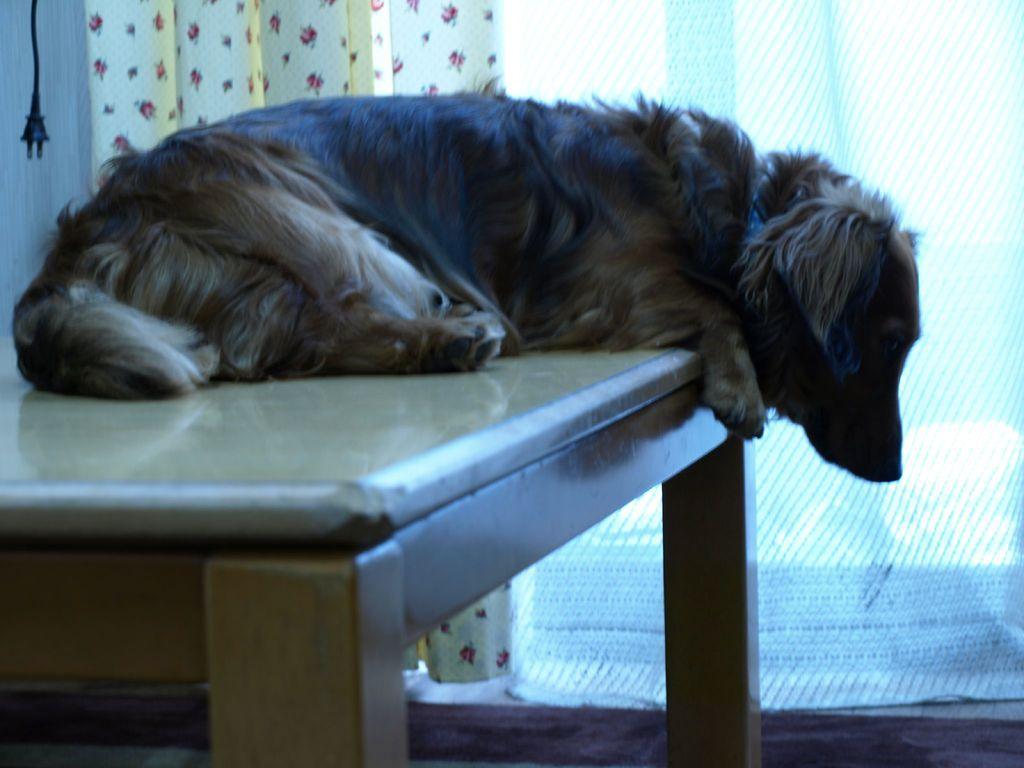Can you describe this image briefly? In this image in the center there is dog sitting on a bench. In the background there is curtain and there is a plug hanging which is black in colour. 